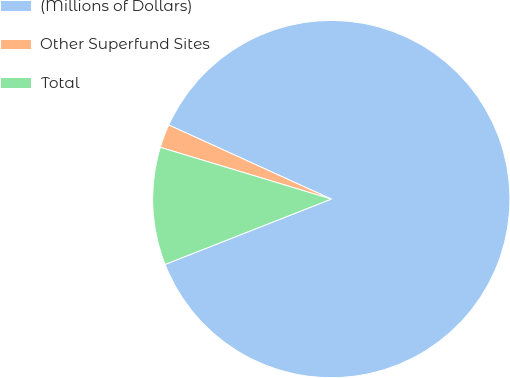<chart> <loc_0><loc_0><loc_500><loc_500><pie_chart><fcel>(Millions of Dollars)<fcel>Other Superfund Sites<fcel>Total<nl><fcel>87.23%<fcel>2.13%<fcel>10.64%<nl></chart> 